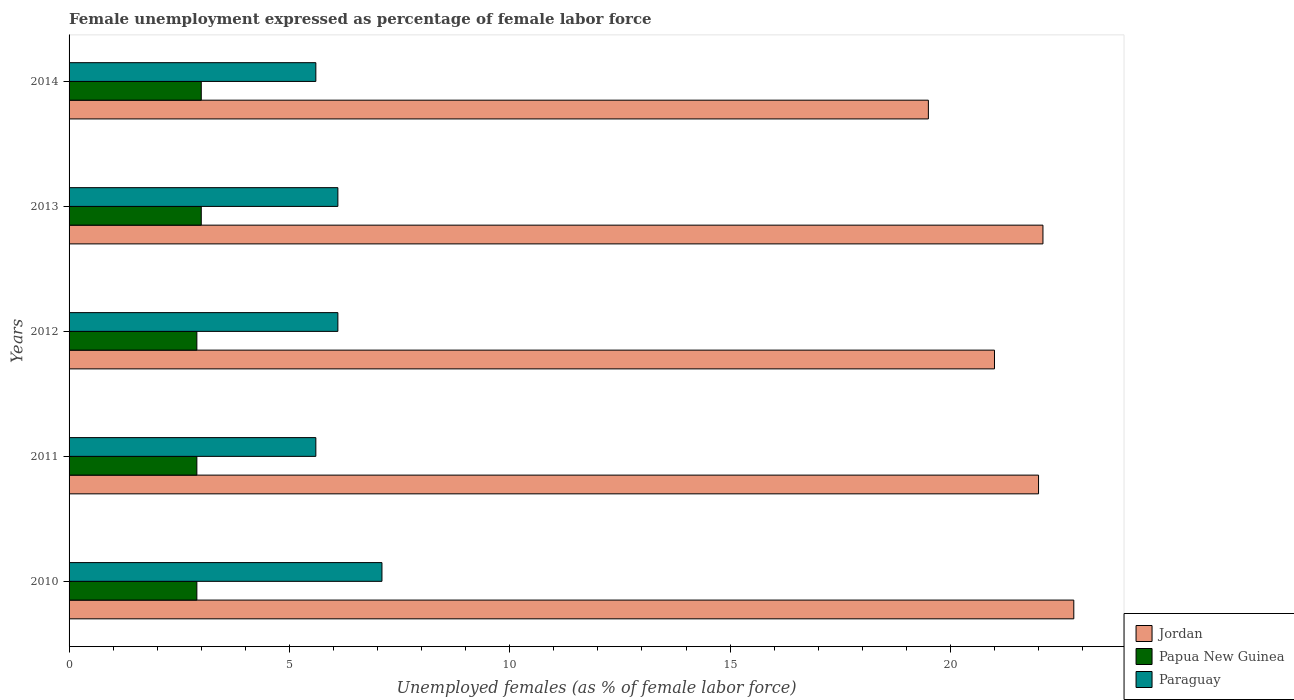How many groups of bars are there?
Your answer should be compact. 5. How many bars are there on the 1st tick from the top?
Provide a succinct answer. 3. How many bars are there on the 5th tick from the bottom?
Provide a short and direct response. 3. What is the label of the 2nd group of bars from the top?
Keep it short and to the point. 2013. In how many cases, is the number of bars for a given year not equal to the number of legend labels?
Make the answer very short. 0. What is the unemployment in females in in Paraguay in 2012?
Keep it short and to the point. 6.1. Across all years, what is the minimum unemployment in females in in Papua New Guinea?
Your answer should be compact. 2.9. In which year was the unemployment in females in in Paraguay maximum?
Provide a short and direct response. 2010. What is the total unemployment in females in in Paraguay in the graph?
Offer a very short reply. 30.5. What is the difference between the unemployment in females in in Jordan in 2010 and that in 2011?
Your answer should be very brief. 0.8. What is the difference between the unemployment in females in in Papua New Guinea in 2011 and the unemployment in females in in Paraguay in 2014?
Your answer should be compact. -2.7. What is the average unemployment in females in in Papua New Guinea per year?
Your answer should be compact. 2.94. In the year 2012, what is the difference between the unemployment in females in in Jordan and unemployment in females in in Paraguay?
Offer a very short reply. 14.9. In how many years, is the unemployment in females in in Jordan greater than 17 %?
Provide a succinct answer. 5. What is the ratio of the unemployment in females in in Jordan in 2012 to that in 2013?
Your answer should be very brief. 0.95. Is the unemployment in females in in Jordan in 2010 less than that in 2012?
Make the answer very short. No. Is the difference between the unemployment in females in in Jordan in 2010 and 2011 greater than the difference between the unemployment in females in in Paraguay in 2010 and 2011?
Your answer should be compact. No. What is the difference between the highest and the lowest unemployment in females in in Jordan?
Keep it short and to the point. 3.3. Is the sum of the unemployment in females in in Papua New Guinea in 2010 and 2012 greater than the maximum unemployment in females in in Jordan across all years?
Your answer should be very brief. No. What does the 3rd bar from the top in 2010 represents?
Offer a terse response. Jordan. What does the 2nd bar from the bottom in 2012 represents?
Provide a short and direct response. Papua New Guinea. Is it the case that in every year, the sum of the unemployment in females in in Papua New Guinea and unemployment in females in in Jordan is greater than the unemployment in females in in Paraguay?
Give a very brief answer. Yes. Are all the bars in the graph horizontal?
Provide a short and direct response. Yes. How many years are there in the graph?
Give a very brief answer. 5. Does the graph contain any zero values?
Ensure brevity in your answer.  No. Does the graph contain grids?
Provide a short and direct response. No. How many legend labels are there?
Offer a terse response. 3. How are the legend labels stacked?
Offer a terse response. Vertical. What is the title of the graph?
Ensure brevity in your answer.  Female unemployment expressed as percentage of female labor force. What is the label or title of the X-axis?
Keep it short and to the point. Unemployed females (as % of female labor force). What is the Unemployed females (as % of female labor force) in Jordan in 2010?
Make the answer very short. 22.8. What is the Unemployed females (as % of female labor force) in Papua New Guinea in 2010?
Offer a terse response. 2.9. What is the Unemployed females (as % of female labor force) of Paraguay in 2010?
Your response must be concise. 7.1. What is the Unemployed females (as % of female labor force) in Papua New Guinea in 2011?
Provide a short and direct response. 2.9. What is the Unemployed females (as % of female labor force) in Paraguay in 2011?
Offer a terse response. 5.6. What is the Unemployed females (as % of female labor force) of Papua New Guinea in 2012?
Offer a terse response. 2.9. What is the Unemployed females (as % of female labor force) of Paraguay in 2012?
Your answer should be very brief. 6.1. What is the Unemployed females (as % of female labor force) in Jordan in 2013?
Provide a short and direct response. 22.1. What is the Unemployed females (as % of female labor force) in Papua New Guinea in 2013?
Make the answer very short. 3. What is the Unemployed females (as % of female labor force) of Paraguay in 2013?
Offer a very short reply. 6.1. What is the Unemployed females (as % of female labor force) in Papua New Guinea in 2014?
Provide a short and direct response. 3. What is the Unemployed females (as % of female labor force) in Paraguay in 2014?
Your response must be concise. 5.6. Across all years, what is the maximum Unemployed females (as % of female labor force) of Jordan?
Provide a succinct answer. 22.8. Across all years, what is the maximum Unemployed females (as % of female labor force) of Paraguay?
Give a very brief answer. 7.1. Across all years, what is the minimum Unemployed females (as % of female labor force) in Papua New Guinea?
Your response must be concise. 2.9. Across all years, what is the minimum Unemployed females (as % of female labor force) of Paraguay?
Make the answer very short. 5.6. What is the total Unemployed females (as % of female labor force) in Jordan in the graph?
Provide a succinct answer. 107.4. What is the total Unemployed females (as % of female labor force) of Papua New Guinea in the graph?
Your answer should be very brief. 14.7. What is the total Unemployed females (as % of female labor force) in Paraguay in the graph?
Provide a short and direct response. 30.5. What is the difference between the Unemployed females (as % of female labor force) of Papua New Guinea in 2010 and that in 2011?
Your answer should be very brief. 0. What is the difference between the Unemployed females (as % of female labor force) of Jordan in 2010 and that in 2012?
Your answer should be very brief. 1.8. What is the difference between the Unemployed females (as % of female labor force) in Papua New Guinea in 2010 and that in 2012?
Give a very brief answer. 0. What is the difference between the Unemployed females (as % of female labor force) in Jordan in 2010 and that in 2013?
Your response must be concise. 0.7. What is the difference between the Unemployed females (as % of female labor force) in Papua New Guinea in 2010 and that in 2013?
Make the answer very short. -0.1. What is the difference between the Unemployed females (as % of female labor force) of Paraguay in 2010 and that in 2013?
Provide a short and direct response. 1. What is the difference between the Unemployed females (as % of female labor force) of Jordan in 2010 and that in 2014?
Offer a very short reply. 3.3. What is the difference between the Unemployed females (as % of female labor force) of Papua New Guinea in 2010 and that in 2014?
Your answer should be very brief. -0.1. What is the difference between the Unemployed females (as % of female labor force) of Papua New Guinea in 2011 and that in 2012?
Provide a succinct answer. 0. What is the difference between the Unemployed females (as % of female labor force) in Jordan in 2011 and that in 2013?
Keep it short and to the point. -0.1. What is the difference between the Unemployed females (as % of female labor force) of Papua New Guinea in 2011 and that in 2014?
Offer a very short reply. -0.1. What is the difference between the Unemployed females (as % of female labor force) in Jordan in 2012 and that in 2013?
Give a very brief answer. -1.1. What is the difference between the Unemployed females (as % of female labor force) of Jordan in 2012 and that in 2014?
Your answer should be very brief. 1.5. What is the difference between the Unemployed females (as % of female labor force) in Papua New Guinea in 2012 and that in 2014?
Give a very brief answer. -0.1. What is the difference between the Unemployed females (as % of female labor force) in Jordan in 2013 and that in 2014?
Ensure brevity in your answer.  2.6. What is the difference between the Unemployed females (as % of female labor force) in Papua New Guinea in 2013 and that in 2014?
Offer a very short reply. 0. What is the difference between the Unemployed females (as % of female labor force) in Jordan in 2010 and the Unemployed females (as % of female labor force) in Papua New Guinea in 2011?
Your answer should be compact. 19.9. What is the difference between the Unemployed females (as % of female labor force) of Jordan in 2010 and the Unemployed females (as % of female labor force) of Paraguay in 2011?
Keep it short and to the point. 17.2. What is the difference between the Unemployed females (as % of female labor force) in Papua New Guinea in 2010 and the Unemployed females (as % of female labor force) in Paraguay in 2011?
Your answer should be compact. -2.7. What is the difference between the Unemployed females (as % of female labor force) of Jordan in 2010 and the Unemployed females (as % of female labor force) of Papua New Guinea in 2012?
Provide a short and direct response. 19.9. What is the difference between the Unemployed females (as % of female labor force) of Jordan in 2010 and the Unemployed females (as % of female labor force) of Paraguay in 2012?
Give a very brief answer. 16.7. What is the difference between the Unemployed females (as % of female labor force) of Jordan in 2010 and the Unemployed females (as % of female labor force) of Papua New Guinea in 2013?
Provide a short and direct response. 19.8. What is the difference between the Unemployed females (as % of female labor force) of Jordan in 2010 and the Unemployed females (as % of female labor force) of Paraguay in 2013?
Provide a short and direct response. 16.7. What is the difference between the Unemployed females (as % of female labor force) of Jordan in 2010 and the Unemployed females (as % of female labor force) of Papua New Guinea in 2014?
Provide a short and direct response. 19.8. What is the difference between the Unemployed females (as % of female labor force) of Papua New Guinea in 2010 and the Unemployed females (as % of female labor force) of Paraguay in 2014?
Provide a short and direct response. -2.7. What is the difference between the Unemployed females (as % of female labor force) of Jordan in 2011 and the Unemployed females (as % of female labor force) of Papua New Guinea in 2012?
Provide a succinct answer. 19.1. What is the difference between the Unemployed females (as % of female labor force) in Papua New Guinea in 2011 and the Unemployed females (as % of female labor force) in Paraguay in 2012?
Your answer should be very brief. -3.2. What is the difference between the Unemployed females (as % of female labor force) of Jordan in 2011 and the Unemployed females (as % of female labor force) of Paraguay in 2013?
Your answer should be very brief. 15.9. What is the difference between the Unemployed females (as % of female labor force) in Papua New Guinea in 2011 and the Unemployed females (as % of female labor force) in Paraguay in 2013?
Provide a short and direct response. -3.2. What is the difference between the Unemployed females (as % of female labor force) in Jordan in 2011 and the Unemployed females (as % of female labor force) in Papua New Guinea in 2014?
Your answer should be very brief. 19. What is the difference between the Unemployed females (as % of female labor force) of Jordan in 2011 and the Unemployed females (as % of female labor force) of Paraguay in 2014?
Offer a terse response. 16.4. What is the difference between the Unemployed females (as % of female labor force) of Papua New Guinea in 2011 and the Unemployed females (as % of female labor force) of Paraguay in 2014?
Your response must be concise. -2.7. What is the difference between the Unemployed females (as % of female labor force) in Jordan in 2012 and the Unemployed females (as % of female labor force) in Papua New Guinea in 2013?
Ensure brevity in your answer.  18. What is the difference between the Unemployed females (as % of female labor force) of Jordan in 2012 and the Unemployed females (as % of female labor force) of Paraguay in 2013?
Give a very brief answer. 14.9. What is the difference between the Unemployed females (as % of female labor force) of Papua New Guinea in 2012 and the Unemployed females (as % of female labor force) of Paraguay in 2013?
Make the answer very short. -3.2. What is the difference between the Unemployed females (as % of female labor force) in Jordan in 2013 and the Unemployed females (as % of female labor force) in Papua New Guinea in 2014?
Your answer should be compact. 19.1. What is the average Unemployed females (as % of female labor force) in Jordan per year?
Make the answer very short. 21.48. What is the average Unemployed females (as % of female labor force) in Papua New Guinea per year?
Offer a terse response. 2.94. What is the average Unemployed females (as % of female labor force) in Paraguay per year?
Ensure brevity in your answer.  6.1. In the year 2010, what is the difference between the Unemployed females (as % of female labor force) of Jordan and Unemployed females (as % of female labor force) of Papua New Guinea?
Give a very brief answer. 19.9. In the year 2010, what is the difference between the Unemployed females (as % of female labor force) in Jordan and Unemployed females (as % of female labor force) in Paraguay?
Keep it short and to the point. 15.7. In the year 2010, what is the difference between the Unemployed females (as % of female labor force) in Papua New Guinea and Unemployed females (as % of female labor force) in Paraguay?
Provide a succinct answer. -4.2. In the year 2012, what is the difference between the Unemployed females (as % of female labor force) in Jordan and Unemployed females (as % of female labor force) in Papua New Guinea?
Offer a terse response. 18.1. In the year 2012, what is the difference between the Unemployed females (as % of female labor force) of Jordan and Unemployed females (as % of female labor force) of Paraguay?
Your response must be concise. 14.9. In the year 2013, what is the difference between the Unemployed females (as % of female labor force) in Jordan and Unemployed females (as % of female labor force) in Papua New Guinea?
Your response must be concise. 19.1. In the year 2014, what is the difference between the Unemployed females (as % of female labor force) of Jordan and Unemployed females (as % of female labor force) of Papua New Guinea?
Ensure brevity in your answer.  16.5. In the year 2014, what is the difference between the Unemployed females (as % of female labor force) of Jordan and Unemployed females (as % of female labor force) of Paraguay?
Offer a very short reply. 13.9. What is the ratio of the Unemployed females (as % of female labor force) of Jordan in 2010 to that in 2011?
Make the answer very short. 1.04. What is the ratio of the Unemployed females (as % of female labor force) in Papua New Guinea in 2010 to that in 2011?
Keep it short and to the point. 1. What is the ratio of the Unemployed females (as % of female labor force) of Paraguay in 2010 to that in 2011?
Ensure brevity in your answer.  1.27. What is the ratio of the Unemployed females (as % of female labor force) in Jordan in 2010 to that in 2012?
Your answer should be compact. 1.09. What is the ratio of the Unemployed females (as % of female labor force) of Papua New Guinea in 2010 to that in 2012?
Provide a succinct answer. 1. What is the ratio of the Unemployed females (as % of female labor force) of Paraguay in 2010 to that in 2012?
Keep it short and to the point. 1.16. What is the ratio of the Unemployed females (as % of female labor force) in Jordan in 2010 to that in 2013?
Make the answer very short. 1.03. What is the ratio of the Unemployed females (as % of female labor force) in Papua New Guinea in 2010 to that in 2013?
Provide a succinct answer. 0.97. What is the ratio of the Unemployed females (as % of female labor force) of Paraguay in 2010 to that in 2013?
Give a very brief answer. 1.16. What is the ratio of the Unemployed females (as % of female labor force) of Jordan in 2010 to that in 2014?
Ensure brevity in your answer.  1.17. What is the ratio of the Unemployed females (as % of female labor force) in Papua New Guinea in 2010 to that in 2014?
Make the answer very short. 0.97. What is the ratio of the Unemployed females (as % of female labor force) in Paraguay in 2010 to that in 2014?
Your answer should be very brief. 1.27. What is the ratio of the Unemployed females (as % of female labor force) of Jordan in 2011 to that in 2012?
Your answer should be compact. 1.05. What is the ratio of the Unemployed females (as % of female labor force) in Papua New Guinea in 2011 to that in 2012?
Provide a short and direct response. 1. What is the ratio of the Unemployed females (as % of female labor force) of Paraguay in 2011 to that in 2012?
Ensure brevity in your answer.  0.92. What is the ratio of the Unemployed females (as % of female labor force) of Jordan in 2011 to that in 2013?
Provide a short and direct response. 1. What is the ratio of the Unemployed females (as % of female labor force) of Papua New Guinea in 2011 to that in 2013?
Make the answer very short. 0.97. What is the ratio of the Unemployed females (as % of female labor force) of Paraguay in 2011 to that in 2013?
Provide a short and direct response. 0.92. What is the ratio of the Unemployed females (as % of female labor force) in Jordan in 2011 to that in 2014?
Provide a succinct answer. 1.13. What is the ratio of the Unemployed females (as % of female labor force) of Papua New Guinea in 2011 to that in 2014?
Provide a succinct answer. 0.97. What is the ratio of the Unemployed females (as % of female labor force) in Jordan in 2012 to that in 2013?
Offer a very short reply. 0.95. What is the ratio of the Unemployed females (as % of female labor force) of Papua New Guinea in 2012 to that in 2013?
Provide a succinct answer. 0.97. What is the ratio of the Unemployed females (as % of female labor force) in Paraguay in 2012 to that in 2013?
Ensure brevity in your answer.  1. What is the ratio of the Unemployed females (as % of female labor force) in Jordan in 2012 to that in 2014?
Provide a short and direct response. 1.08. What is the ratio of the Unemployed females (as % of female labor force) of Papua New Guinea in 2012 to that in 2014?
Make the answer very short. 0.97. What is the ratio of the Unemployed females (as % of female labor force) of Paraguay in 2012 to that in 2014?
Offer a terse response. 1.09. What is the ratio of the Unemployed females (as % of female labor force) of Jordan in 2013 to that in 2014?
Give a very brief answer. 1.13. What is the ratio of the Unemployed females (as % of female labor force) of Paraguay in 2013 to that in 2014?
Ensure brevity in your answer.  1.09. What is the difference between the highest and the second highest Unemployed females (as % of female labor force) in Jordan?
Ensure brevity in your answer.  0.7. What is the difference between the highest and the second highest Unemployed females (as % of female labor force) of Papua New Guinea?
Your response must be concise. 0. What is the difference between the highest and the second highest Unemployed females (as % of female labor force) of Paraguay?
Your answer should be very brief. 1. What is the difference between the highest and the lowest Unemployed females (as % of female labor force) in Jordan?
Ensure brevity in your answer.  3.3. What is the difference between the highest and the lowest Unemployed females (as % of female labor force) of Paraguay?
Offer a very short reply. 1.5. 